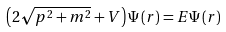<formula> <loc_0><loc_0><loc_500><loc_500>\left ( 2 \sqrt { p ^ { 2 } + m ^ { 2 } } + V \right ) \Psi \left ( r \right ) = E \Psi \left ( r \right )</formula> 